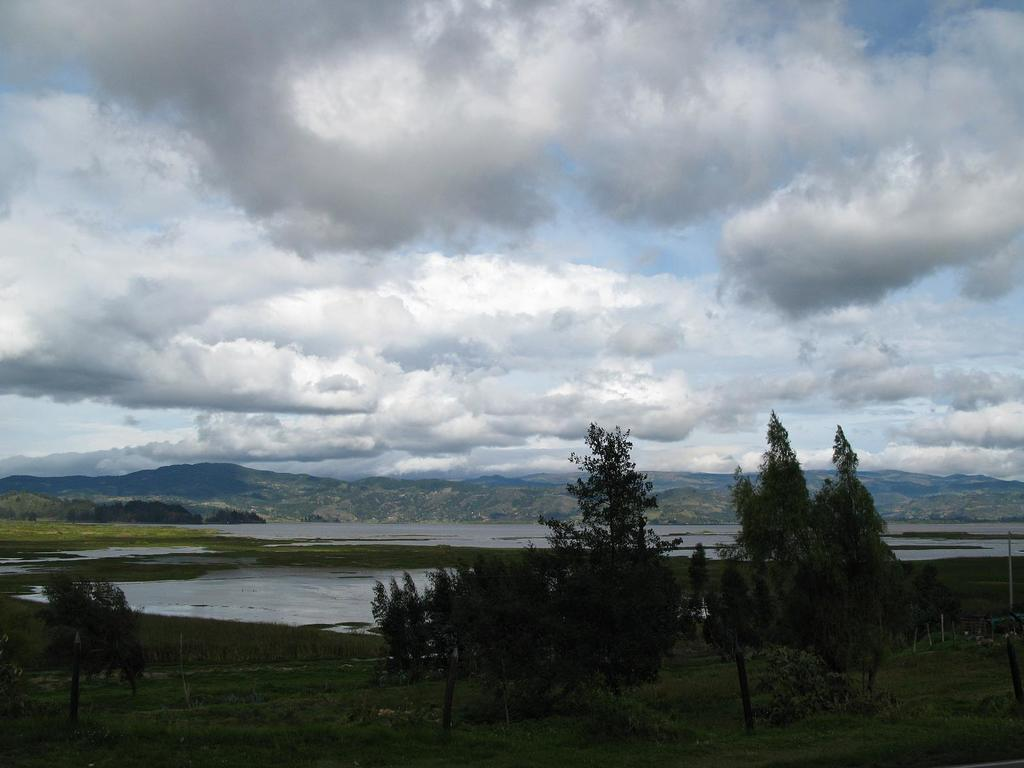What type of vegetation can be seen in the image? There is grass and trees visible in the image. What structures are present in the image? There are poles visible in the image. What natural feature can be seen in the image? There is water visible in the image. What is visible in the background of the image? There are hills and sky visible in the background of the image. What can be seen in the sky in the image? Clouds are present in the sky. What type of pipe is visible in the image? There is no pipe present in the image. How does the image depict the act of saying good-bye? The image does not depict any act of saying good-bye. 